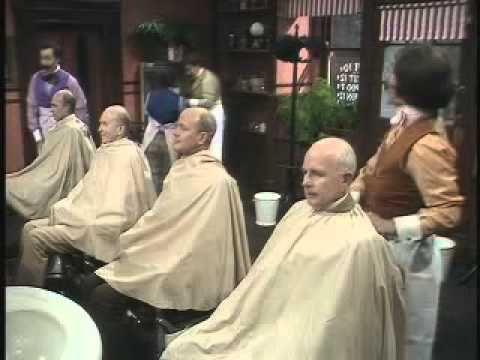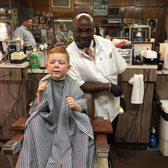The first image is the image on the left, the second image is the image on the right. Given the left and right images, does the statement "In one image, a child is draped in a barber's cape and getting a haircut" hold true? Answer yes or no. Yes. 